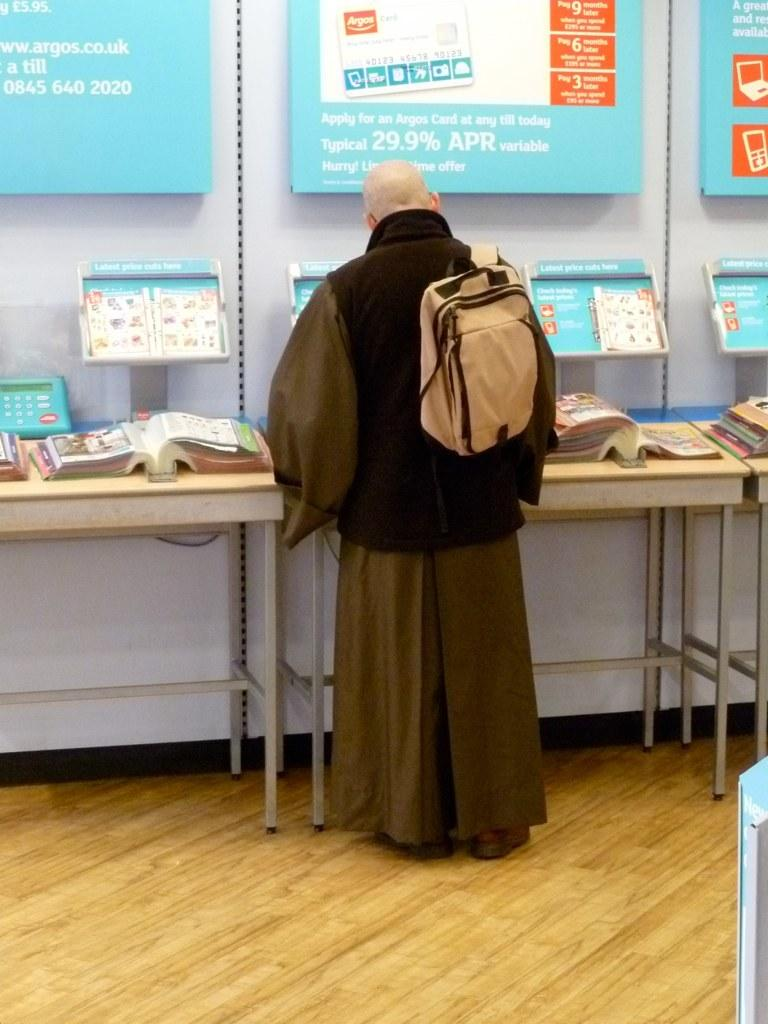What is the main subject in the room? There is a man standing in the room. What is the man wearing? The man is wearing a cream-colored bag. What large object can be seen in the room? There is a huge book in the room. What is hanging above the book? Above the book, there are some posters. How does the man adjust the mist in the room? There is no mention of mist in the image, so it is not possible to determine how the man might adjust it. 